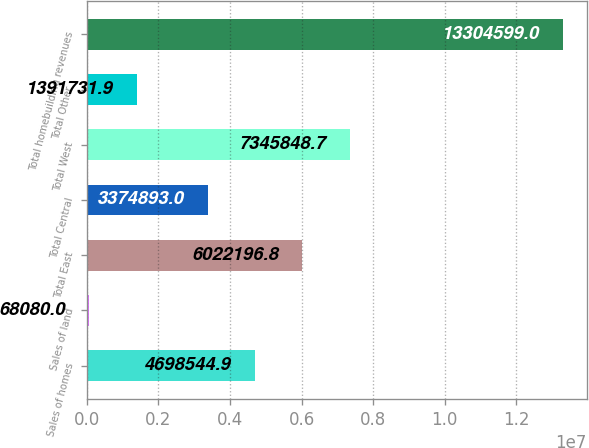Convert chart. <chart><loc_0><loc_0><loc_500><loc_500><bar_chart><fcel>Sales of homes<fcel>Sales of land<fcel>Total East<fcel>Total Central<fcel>Total West<fcel>Total Other<fcel>Total homebuilding revenues<nl><fcel>4.69854e+06<fcel>68080<fcel>6.0222e+06<fcel>3.37489e+06<fcel>7.34585e+06<fcel>1.39173e+06<fcel>1.33046e+07<nl></chart> 